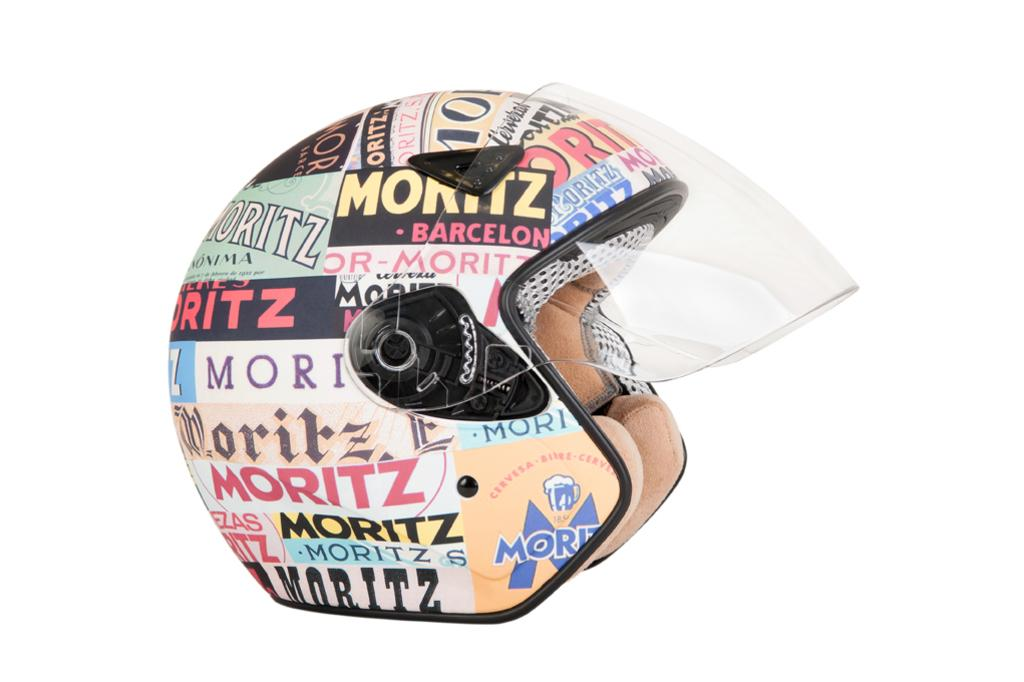What type of protective gear is visible in the image? There is a helmet in the image. What type of book is the person reading in the image? There is no person or book present in the image; only a helmet is visible. 